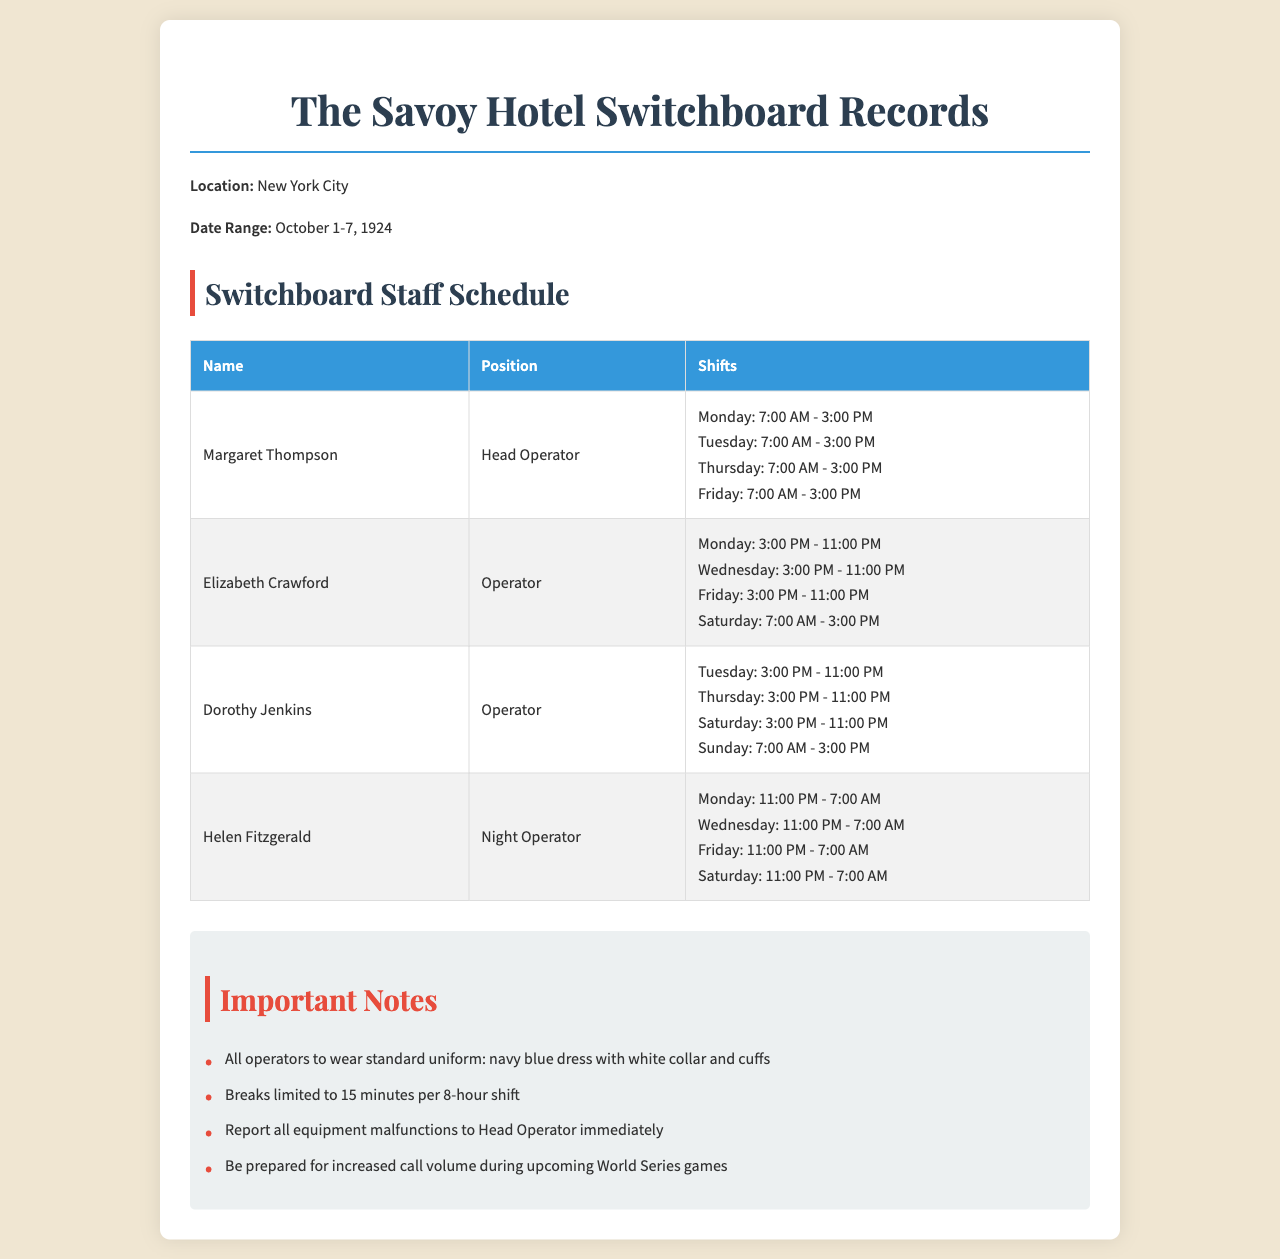What is the name of the Head Operator? The Head Operator's name is listed in the schedule under their position.
Answer: Margaret Thompson How many operators worked the night shift? The document specifies each operator and their shifts, categorizing one as a Night Operator.
Answer: 1 What day did Dorothy Jenkins work the morning shift? The shifts for Dorothy Jenkins are detailed with specific days mentioned.
Answer: Sunday What are the uniform colors for the operators? The document notes the required uniform colors for the telephone operators.
Answer: Navy blue with white Which day had the most operators scheduled? By analyzing the schedule, multiple operators are listed for a day.
Answer: Saturday What was the duration of each operator's break? The document outlines the regulations regarding breaks during shifts.
Answer: 15 minutes What is the total number of shifts Margaret Thompson worked? The number of shifts can be counted from Margaret's schedule provided in the document.
Answer: 4 What equipment issue needs to be reported immediately? The notes section mentions specific actions regarding equipment malfunctions.
Answer: Malfunctions When is the expected increase in call volume? The notes highlight a special event anticipated to increase call volume.
Answer: World Series games 